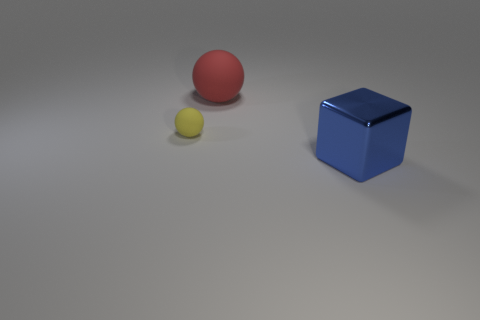There is a big blue metallic cube; are there any tiny things to the right of it?
Your answer should be compact. No. What number of other small yellow objects are the same shape as the metal thing?
Your answer should be very brief. 0. The big thing that is to the left of the big object that is in front of the rubber object left of the big rubber thing is what color?
Offer a terse response. Red. Are the large object that is behind the big blue shiny thing and the large thing that is in front of the small yellow sphere made of the same material?
Make the answer very short. No. How many objects are objects on the right side of the red thing or tiny brown metallic balls?
Your response must be concise. 1. How many things are either yellow blocks or big objects in front of the big red rubber object?
Ensure brevity in your answer.  1. How many yellow matte balls have the same size as the shiny cube?
Your response must be concise. 0. Is the number of large red matte balls that are in front of the large blue shiny object less than the number of tiny matte things that are behind the yellow rubber ball?
Keep it short and to the point. No. How many rubber things are gray spheres or cubes?
Make the answer very short. 0. There is a small yellow object; what shape is it?
Give a very brief answer. Sphere. 